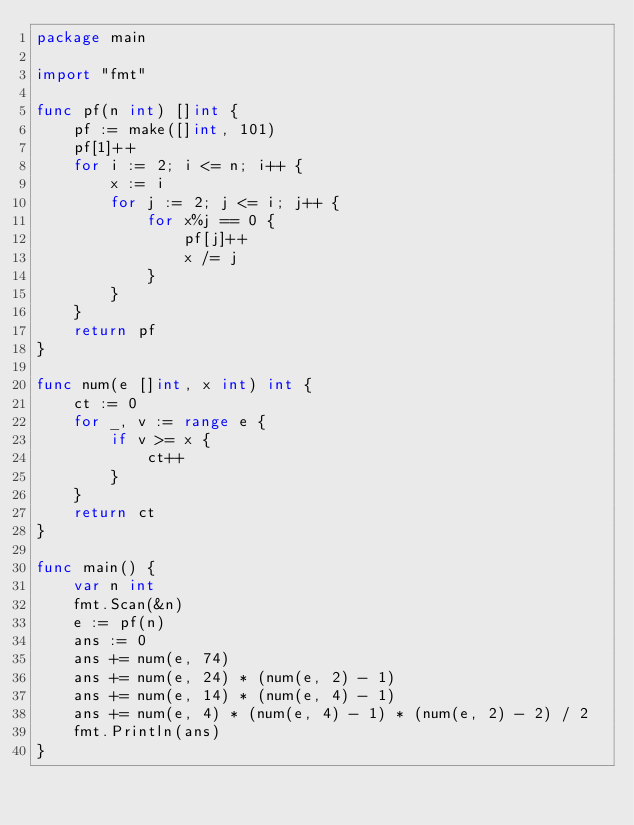<code> <loc_0><loc_0><loc_500><loc_500><_Go_>package main

import "fmt"

func pf(n int) []int {
	pf := make([]int, 101)
	pf[1]++
	for i := 2; i <= n; i++ {
		x := i
		for j := 2; j <= i; j++ {
			for x%j == 0 {
				pf[j]++
				x /= j
			}
		}
	}
	return pf
}

func num(e []int, x int) int {
	ct := 0
	for _, v := range e {
		if v >= x {
			ct++
		}
	}
	return ct
}

func main() {
	var n int
	fmt.Scan(&n)
	e := pf(n)
	ans := 0
	ans += num(e, 74)
	ans += num(e, 24) * (num(e, 2) - 1)
	ans += num(e, 14) * (num(e, 4) - 1)
	ans += num(e, 4) * (num(e, 4) - 1) * (num(e, 2) - 2) / 2
	fmt.Println(ans)
}
</code> 